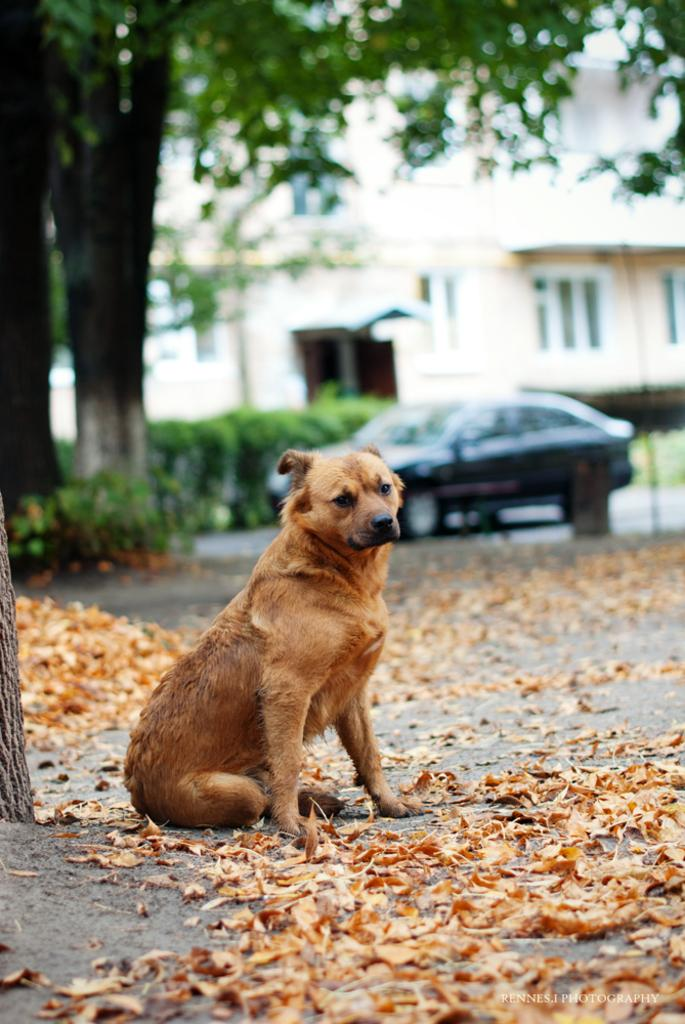What animal is sitting on the land in the image? There is a dog sitting on the land in the image. What is the condition of the land? The land has dried leaves. What type of vegetation is present on the land? Trees and plants are present on the land. What can be seen on the road in the image? There is a car on the road. What is visible in the background of the image? Plants and a building are visible in the background. How does the dog's digestion process appear in the image? There is no indication of the dog's digestion process in the image. Can you see a monkey in the image? No, there is no monkey present in the image. 